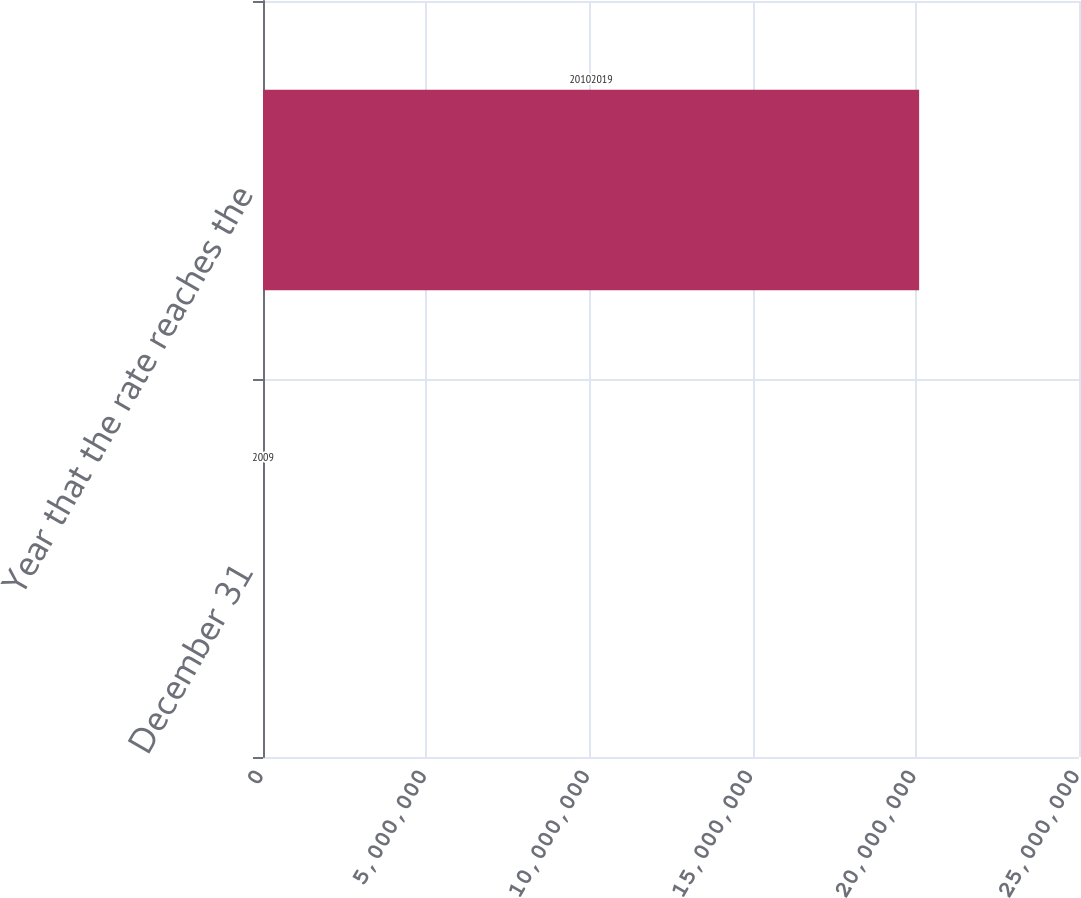<chart> <loc_0><loc_0><loc_500><loc_500><bar_chart><fcel>December 31<fcel>Year that the rate reaches the<nl><fcel>2009<fcel>2.0102e+07<nl></chart> 